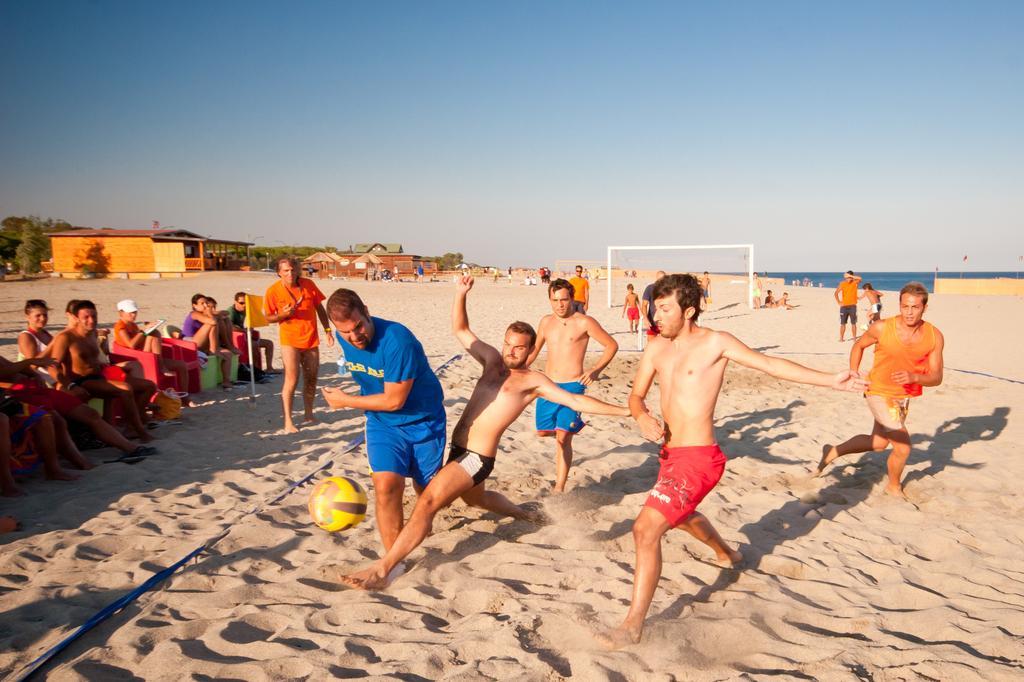Could you give a brief overview of what you see in this image? In this image we can see people playing a game. At the bottom there is a ball and we can see people sitting. In the background there is a net, sheds, trees and sky. On the right there is water. At the bottom there is sand. 